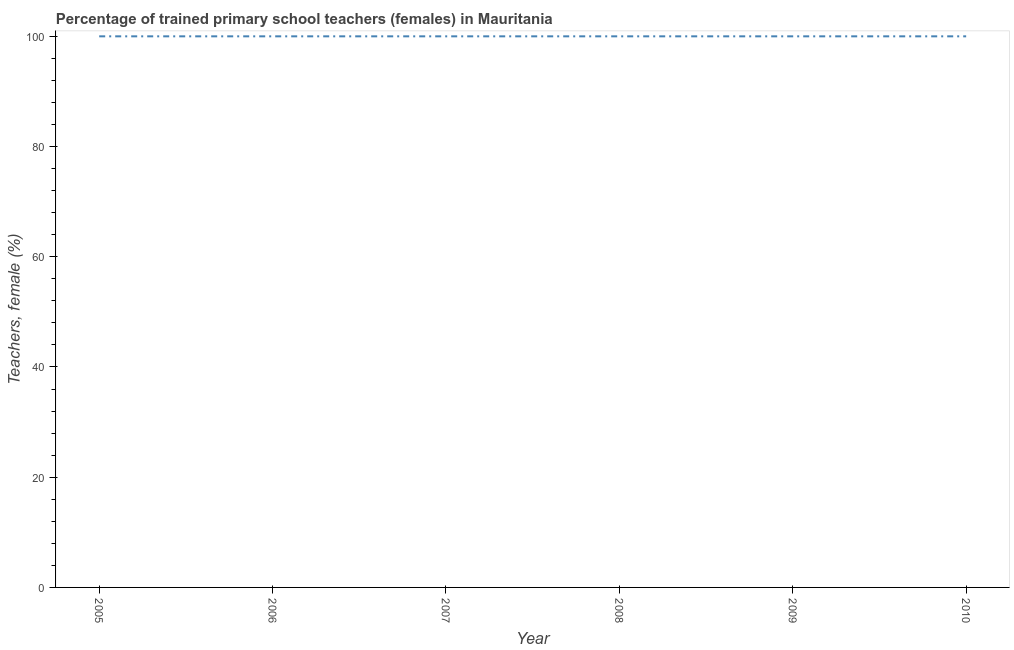What is the percentage of trained female teachers in 2005?
Provide a succinct answer. 100. Across all years, what is the maximum percentage of trained female teachers?
Ensure brevity in your answer.  100. Across all years, what is the minimum percentage of trained female teachers?
Your answer should be very brief. 100. What is the sum of the percentage of trained female teachers?
Keep it short and to the point. 600. What is the difference between the percentage of trained female teachers in 2006 and 2007?
Your answer should be compact. 0. What is the median percentage of trained female teachers?
Offer a very short reply. 100. What is the ratio of the percentage of trained female teachers in 2005 to that in 2009?
Keep it short and to the point. 1. Is the difference between the percentage of trained female teachers in 2005 and 2008 greater than the difference between any two years?
Provide a short and direct response. Yes. Is the sum of the percentage of trained female teachers in 2005 and 2010 greater than the maximum percentage of trained female teachers across all years?
Your answer should be very brief. Yes. What is the difference between the highest and the lowest percentage of trained female teachers?
Your response must be concise. 0. Does the percentage of trained female teachers monotonically increase over the years?
Give a very brief answer. No. How many lines are there?
Your answer should be very brief. 1. How many years are there in the graph?
Your answer should be very brief. 6. What is the difference between two consecutive major ticks on the Y-axis?
Offer a very short reply. 20. Are the values on the major ticks of Y-axis written in scientific E-notation?
Ensure brevity in your answer.  No. Does the graph contain any zero values?
Make the answer very short. No. Does the graph contain grids?
Your answer should be very brief. No. What is the title of the graph?
Your answer should be compact. Percentage of trained primary school teachers (females) in Mauritania. What is the label or title of the X-axis?
Provide a short and direct response. Year. What is the label or title of the Y-axis?
Provide a succinct answer. Teachers, female (%). What is the Teachers, female (%) in 2005?
Your answer should be very brief. 100. What is the Teachers, female (%) in 2006?
Ensure brevity in your answer.  100. What is the Teachers, female (%) in 2007?
Provide a short and direct response. 100. What is the Teachers, female (%) in 2010?
Offer a very short reply. 100. What is the difference between the Teachers, female (%) in 2005 and 2007?
Ensure brevity in your answer.  0. What is the difference between the Teachers, female (%) in 2005 and 2008?
Keep it short and to the point. 0. What is the difference between the Teachers, female (%) in 2005 and 2010?
Your response must be concise. 0. What is the difference between the Teachers, female (%) in 2006 and 2009?
Provide a short and direct response. 0. What is the difference between the Teachers, female (%) in 2006 and 2010?
Offer a terse response. 0. What is the difference between the Teachers, female (%) in 2007 and 2010?
Offer a terse response. 0. What is the difference between the Teachers, female (%) in 2009 and 2010?
Keep it short and to the point. 0. What is the ratio of the Teachers, female (%) in 2005 to that in 2006?
Your answer should be compact. 1. What is the ratio of the Teachers, female (%) in 2005 to that in 2007?
Your answer should be very brief. 1. What is the ratio of the Teachers, female (%) in 2005 to that in 2008?
Your answer should be very brief. 1. What is the ratio of the Teachers, female (%) in 2005 to that in 2009?
Keep it short and to the point. 1. What is the ratio of the Teachers, female (%) in 2006 to that in 2009?
Your answer should be very brief. 1. What is the ratio of the Teachers, female (%) in 2006 to that in 2010?
Make the answer very short. 1. What is the ratio of the Teachers, female (%) in 2008 to that in 2009?
Make the answer very short. 1. What is the ratio of the Teachers, female (%) in 2008 to that in 2010?
Offer a very short reply. 1. What is the ratio of the Teachers, female (%) in 2009 to that in 2010?
Your response must be concise. 1. 